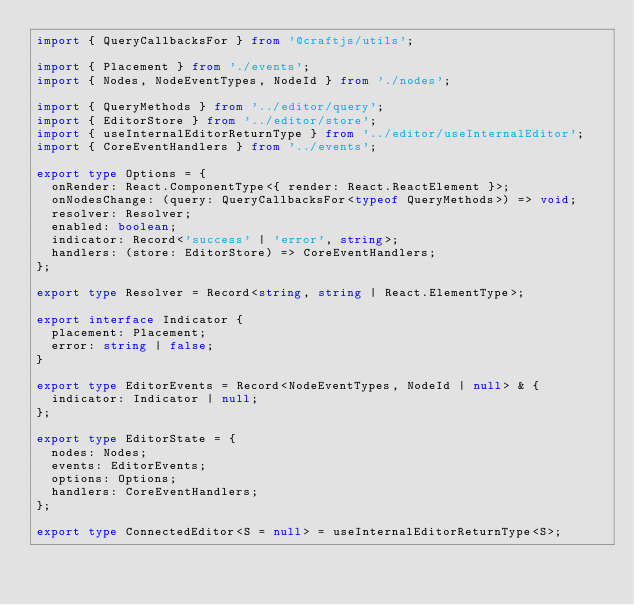<code> <loc_0><loc_0><loc_500><loc_500><_TypeScript_>import { QueryCallbacksFor } from '@craftjs/utils';

import { Placement } from './events';
import { Nodes, NodeEventTypes, NodeId } from './nodes';

import { QueryMethods } from '../editor/query';
import { EditorStore } from '../editor/store';
import { useInternalEditorReturnType } from '../editor/useInternalEditor';
import { CoreEventHandlers } from '../events';

export type Options = {
  onRender: React.ComponentType<{ render: React.ReactElement }>;
  onNodesChange: (query: QueryCallbacksFor<typeof QueryMethods>) => void;
  resolver: Resolver;
  enabled: boolean;
  indicator: Record<'success' | 'error', string>;
  handlers: (store: EditorStore) => CoreEventHandlers;
};

export type Resolver = Record<string, string | React.ElementType>;

export interface Indicator {
  placement: Placement;
  error: string | false;
}

export type EditorEvents = Record<NodeEventTypes, NodeId | null> & {
  indicator: Indicator | null;
};

export type EditorState = {
  nodes: Nodes;
  events: EditorEvents;
  options: Options;
  handlers: CoreEventHandlers;
};

export type ConnectedEditor<S = null> = useInternalEditorReturnType<S>;
</code> 